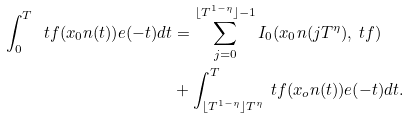<formula> <loc_0><loc_0><loc_500><loc_500>\int _ { 0 } ^ { T } \ t f ( x _ { 0 } n ( t ) ) e ( - t ) d t & = \sum _ { j = 0 } ^ { \lfloor T ^ { 1 - \eta } \rfloor - 1 } I _ { 0 } ( x _ { 0 } n ( j T ^ { \eta } ) , \ t f ) \\ & + \int _ { \lfloor T ^ { 1 - \eta } \rfloor T ^ { \eta } } ^ { T } \ t f ( x _ { o } n ( t ) ) e ( - t ) d t .</formula> 